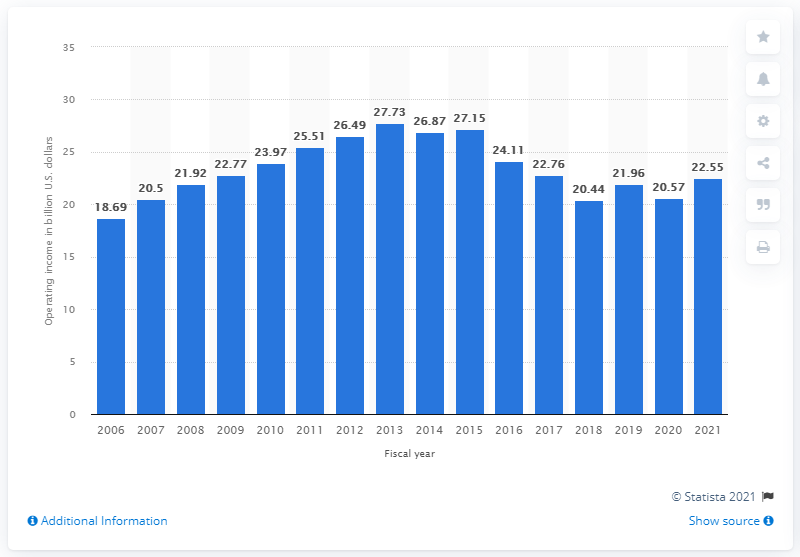List a handful of essential elements in this visual. In 2021, Walmart's global operating income reached 22.6 billion U.S. dollars. In 2021, Walmart's global operating income was 22.55 billion dollars. 